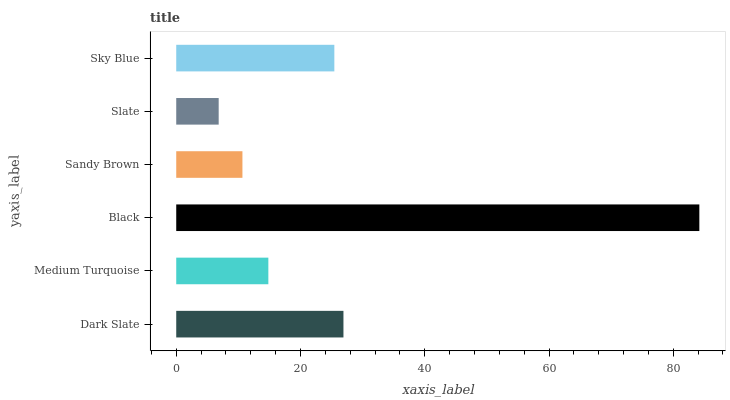Is Slate the minimum?
Answer yes or no. Yes. Is Black the maximum?
Answer yes or no. Yes. Is Medium Turquoise the minimum?
Answer yes or no. No. Is Medium Turquoise the maximum?
Answer yes or no. No. Is Dark Slate greater than Medium Turquoise?
Answer yes or no. Yes. Is Medium Turquoise less than Dark Slate?
Answer yes or no. Yes. Is Medium Turquoise greater than Dark Slate?
Answer yes or no. No. Is Dark Slate less than Medium Turquoise?
Answer yes or no. No. Is Sky Blue the high median?
Answer yes or no. Yes. Is Medium Turquoise the low median?
Answer yes or no. Yes. Is Sandy Brown the high median?
Answer yes or no. No. Is Slate the low median?
Answer yes or no. No. 